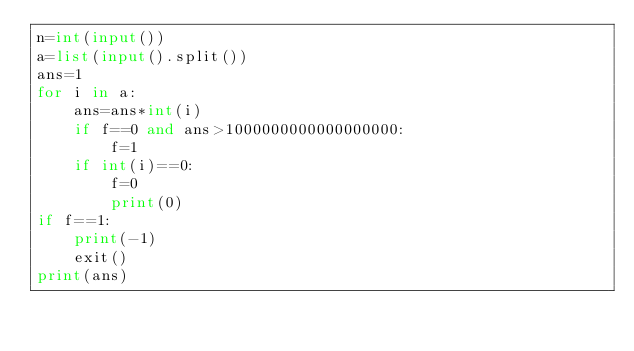Convert code to text. <code><loc_0><loc_0><loc_500><loc_500><_Python_>n=int(input())
a=list(input().split())
ans=1
for i in a:
    ans=ans*int(i)
    if f==0 and ans>1000000000000000000:
        f=1
    if int(i)==0:
        f=0
        print(0)
if f==1:
    print(-1)
    exit()
print(ans)</code> 